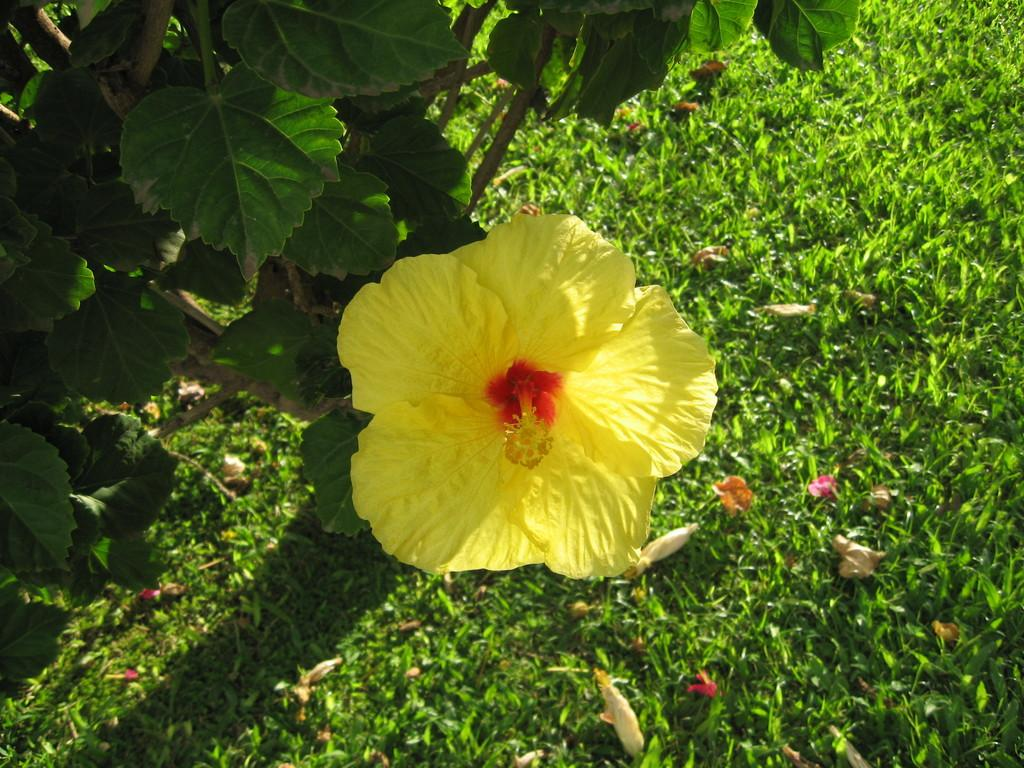What type of flower can be seen in the image? There is a yellow flower in the image. What type of vegetation is visible in the image? There is grass visible in the image. Where is the plant located in the image? The plant is on the top left of the image. What are the green parts of the plants called in the image? Leaves are present in the image. How much money is being exchanged between the plants in the image? There is no money present in the image, as it features plants and flowers. 